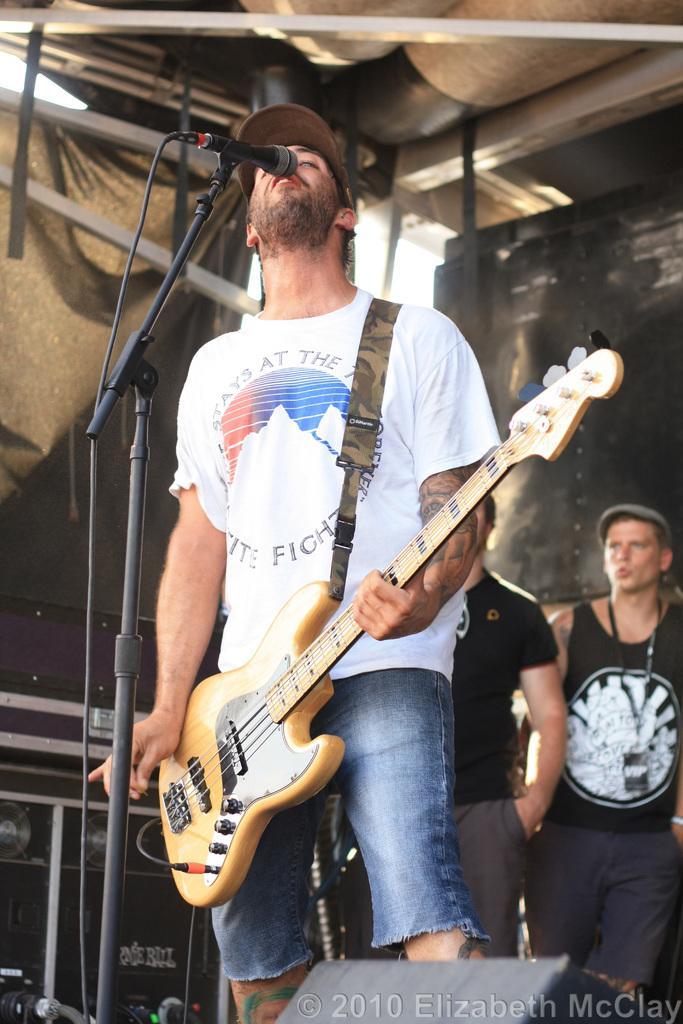Please provide a concise description of this image. A man is standing and also holding a guitar and singing in the microphone he wear a cap behind him there are two persons standing and looking at him. 